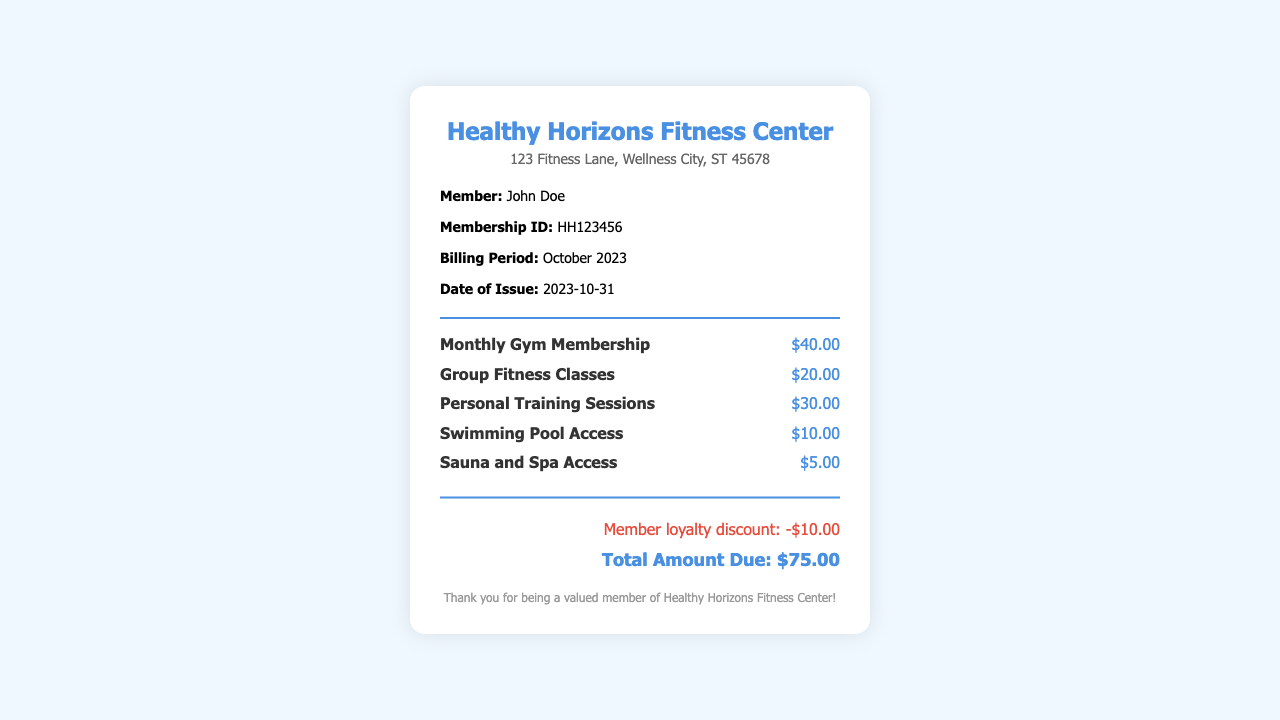What is the name of the gym? The gym's name is displayed prominently at the top of the receipt.
Answer: Healthy Horizons Fitness Center Who is the member on this receipt? The member's name is stated in the member info section of the receipt.
Answer: John Doe What is the membership ID? The membership ID is provided in the member info section.
Answer: HH123456 What is the total amount due? The total amount due is listed at the bottom of the receipt.
Answer: $75.00 How much is the monthly gym membership? The cost of the monthly gym membership is specified in the services section.
Answer: $40.00 What discount was applied to the total? The applied discount is mentioned in the discount section of the receipt.
Answer: -$10.00 What services are included in the receipt? The services are detailed in the services section, listing various activities and their costs.
Answer: Monthly Gym Membership, Group Fitness Classes, Personal Training Sessions, Swimming Pool Access, Sauna and Spa Access What is the billing period for this receipt? The billing period is clearly stated in the member info section.
Answer: October 2023 On what date was this receipt issued? The date of issue is specified in the member info section.
Answer: 2023-10-31 